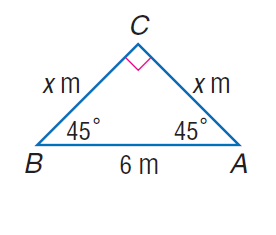Question: Find x.
Choices:
A. 3
B. 3 \sqrt { 2 }
C. 6
D. 6 \sqrt { 2 }
Answer with the letter. Answer: B 